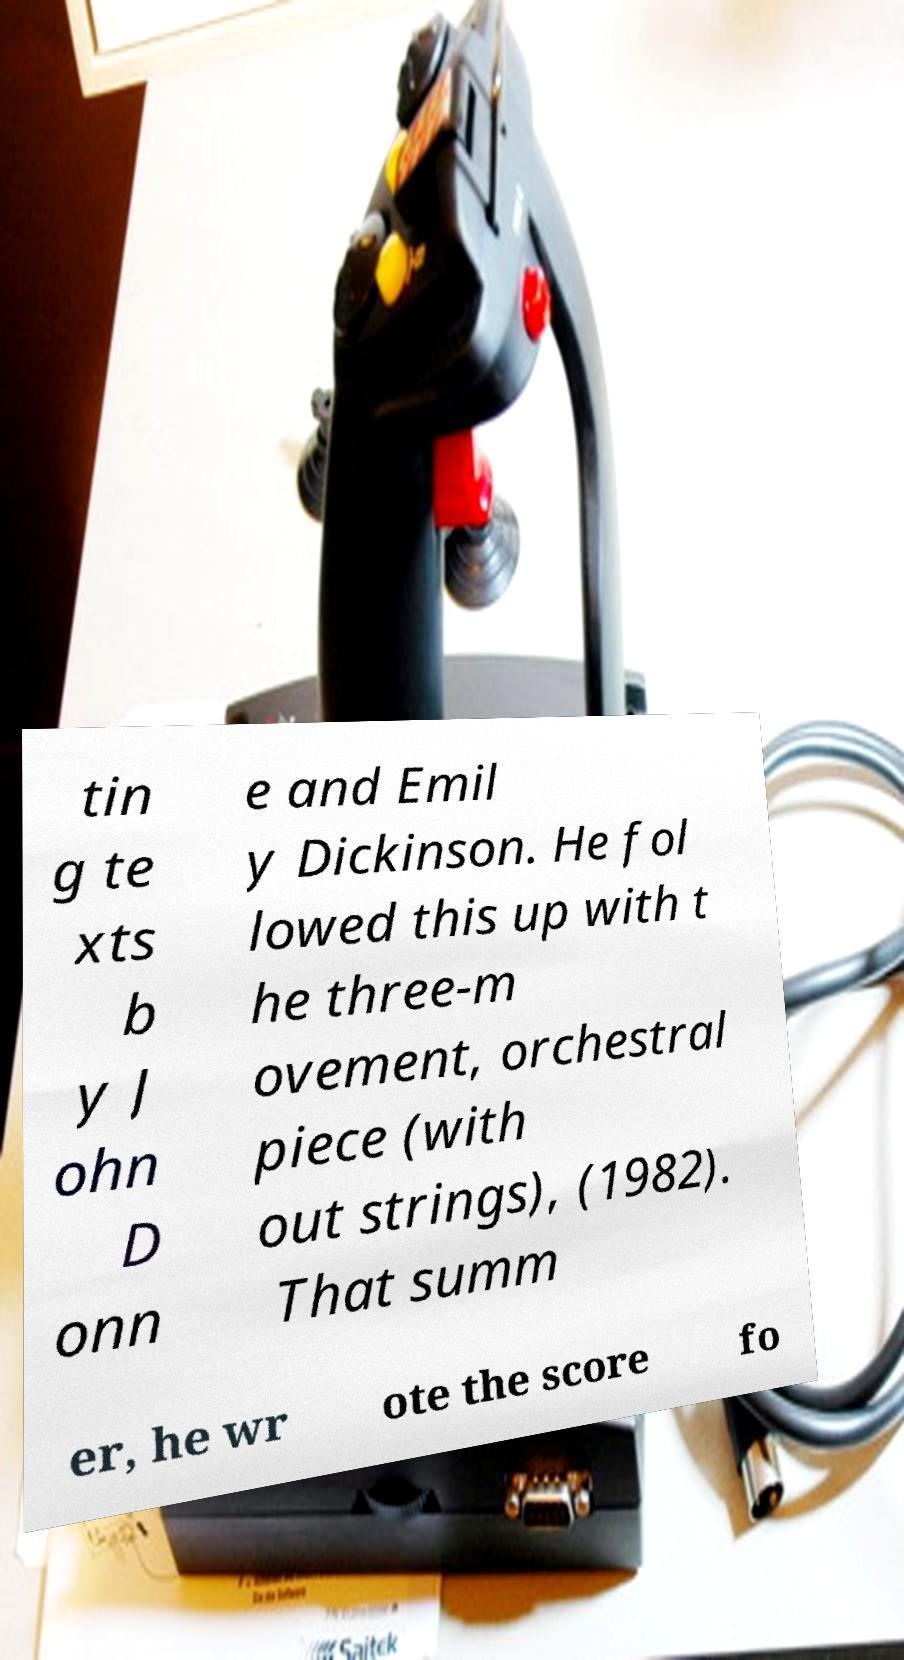Please read and relay the text visible in this image. What does it say? tin g te xts b y J ohn D onn e and Emil y Dickinson. He fol lowed this up with t he three-m ovement, orchestral piece (with out strings), (1982). That summ er, he wr ote the score fo 